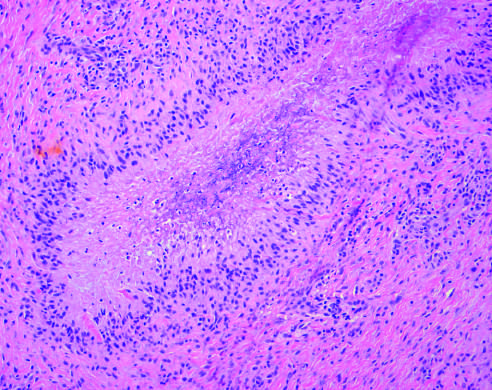how is rheumatoid nodule composed of central necrosis rimmed?
Answer the question using a single word or phrase. By palisaded histiocytes 